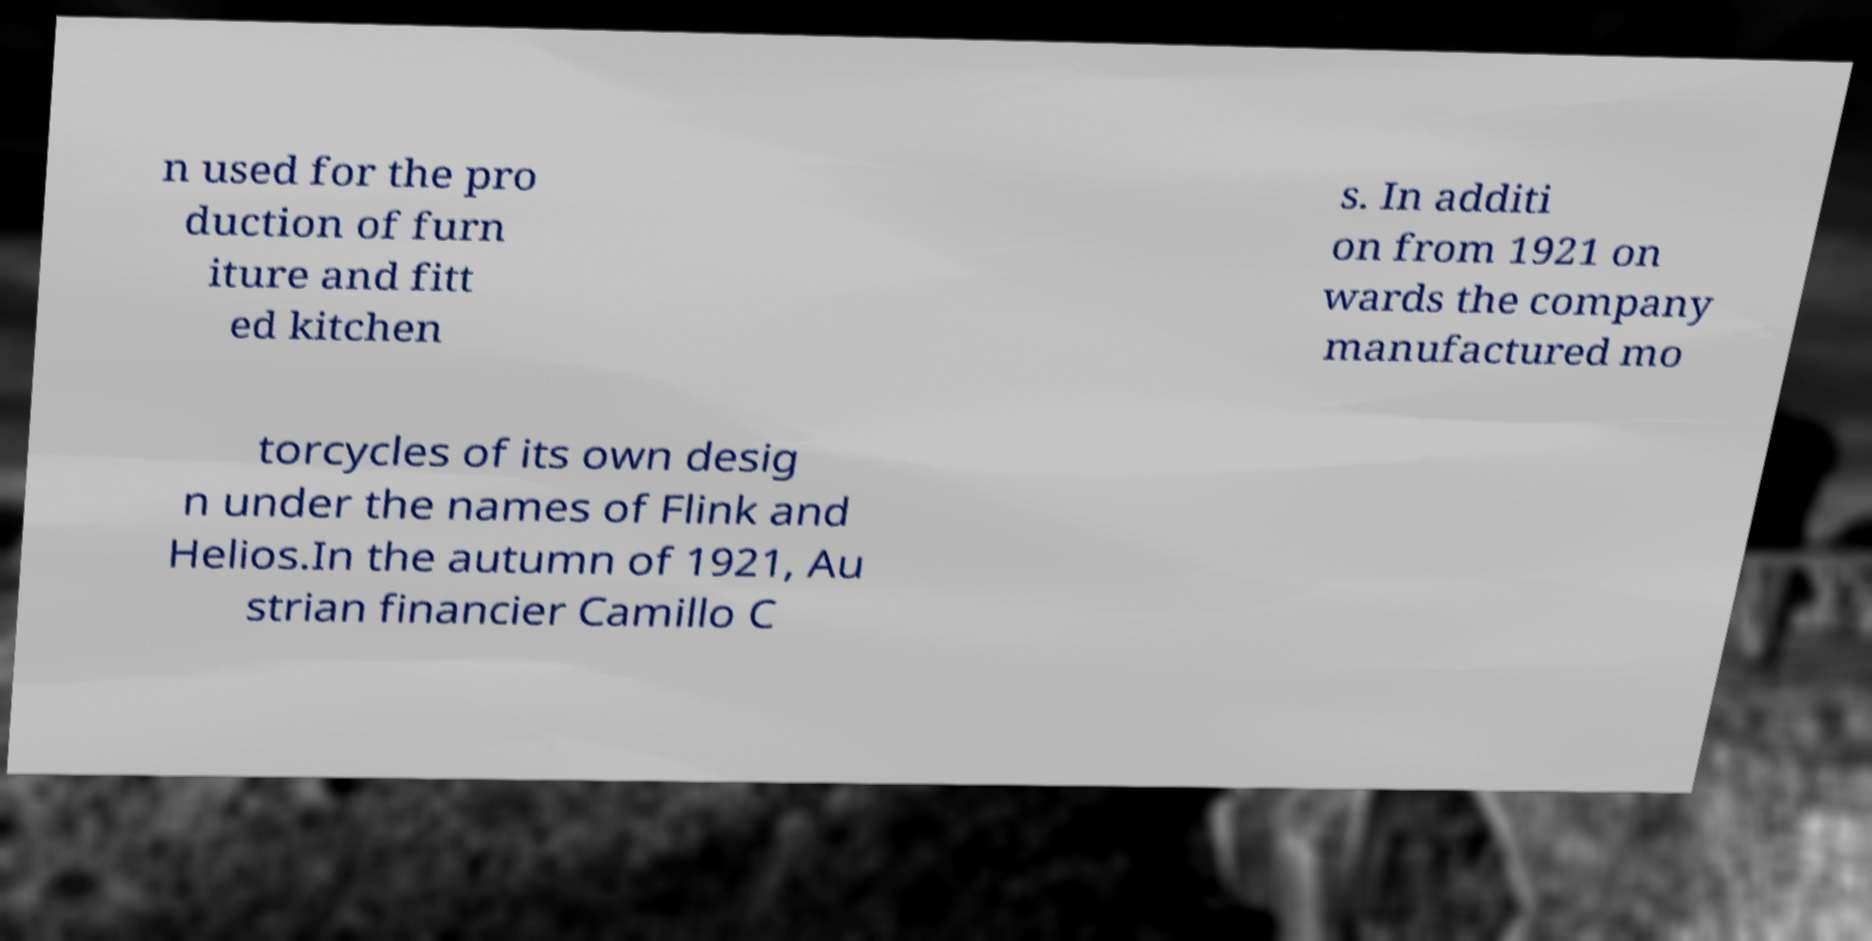Please read and relay the text visible in this image. What does it say? n used for the pro duction of furn iture and fitt ed kitchen s. In additi on from 1921 on wards the company manufactured mo torcycles of its own desig n under the names of Flink and Helios.In the autumn of 1921, Au strian financier Camillo C 